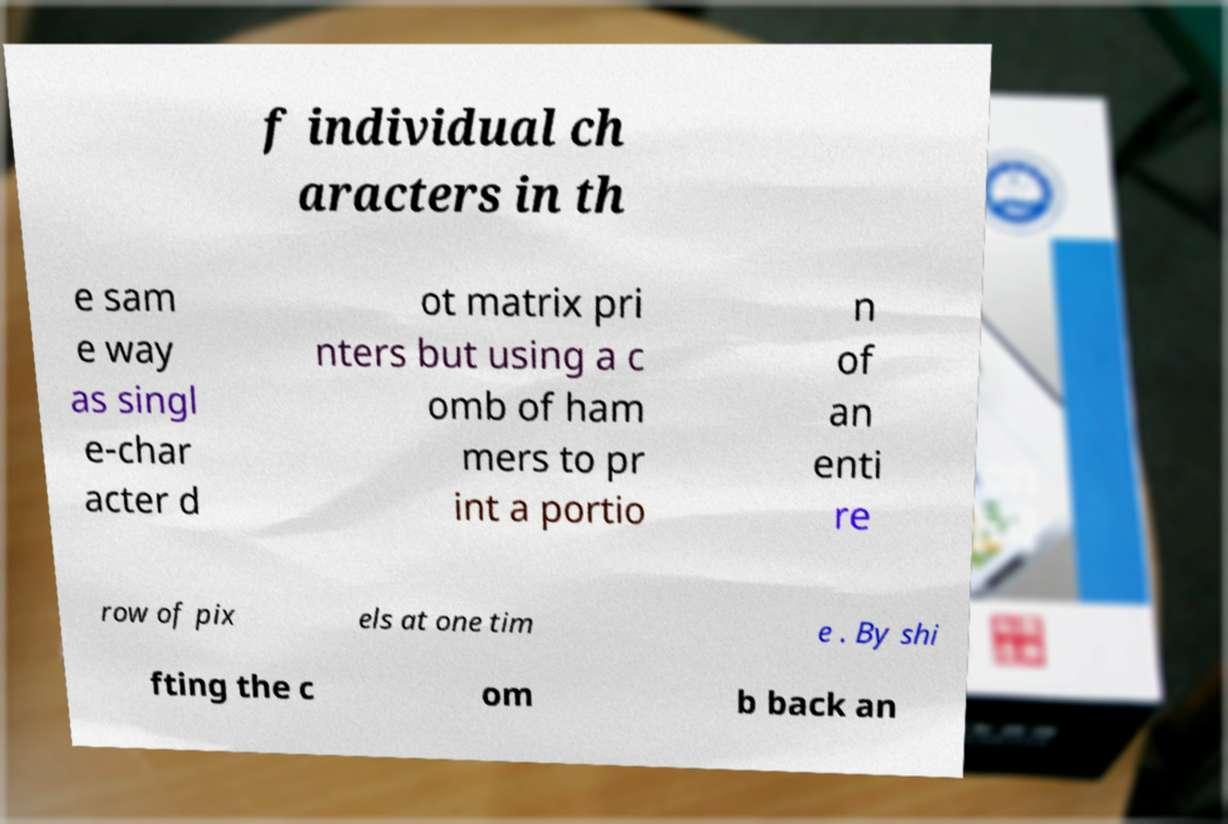Please read and relay the text visible in this image. What does it say? f individual ch aracters in th e sam e way as singl e-char acter d ot matrix pri nters but using a c omb of ham mers to pr int a portio n of an enti re row of pix els at one tim e . By shi fting the c om b back an 